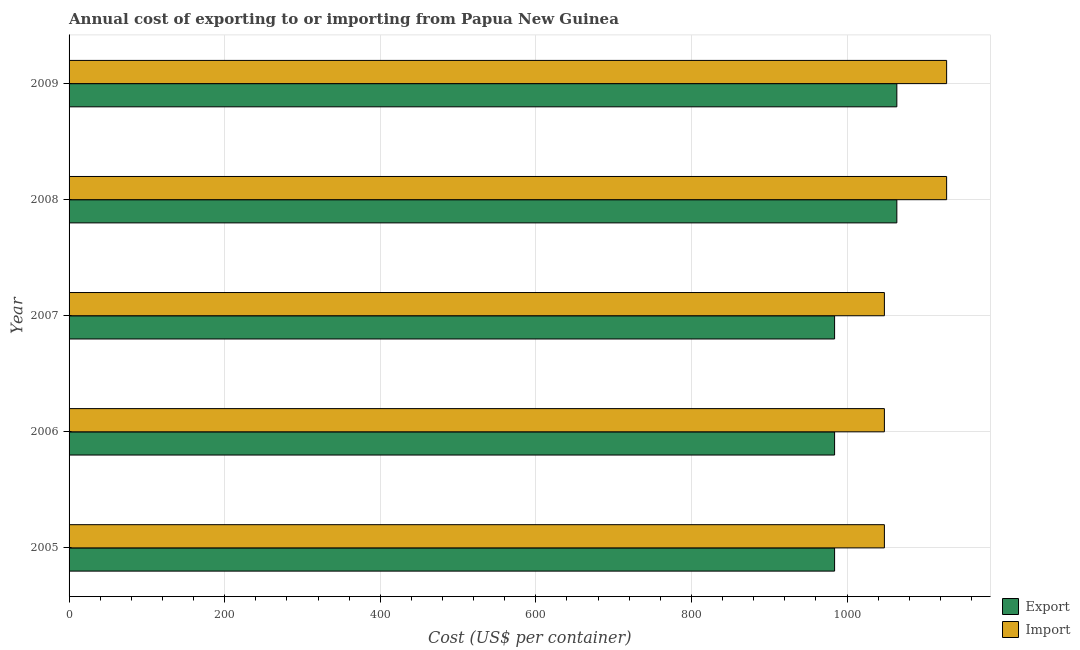How many different coloured bars are there?
Make the answer very short. 2. How many groups of bars are there?
Your response must be concise. 5. Are the number of bars per tick equal to the number of legend labels?
Offer a very short reply. Yes. How many bars are there on the 5th tick from the top?
Keep it short and to the point. 2. How many bars are there on the 2nd tick from the bottom?
Keep it short and to the point. 2. In how many cases, is the number of bars for a given year not equal to the number of legend labels?
Your response must be concise. 0. What is the import cost in 2008?
Your response must be concise. 1128. Across all years, what is the maximum export cost?
Provide a short and direct response. 1064. Across all years, what is the minimum export cost?
Your answer should be compact. 984. In which year was the export cost maximum?
Provide a succinct answer. 2008. In which year was the export cost minimum?
Offer a terse response. 2005. What is the total export cost in the graph?
Keep it short and to the point. 5080. What is the difference between the import cost in 2007 and that in 2008?
Your answer should be very brief. -80. What is the difference between the import cost in 2005 and the export cost in 2007?
Your answer should be very brief. 64. What is the average export cost per year?
Offer a very short reply. 1016. In the year 2005, what is the difference between the import cost and export cost?
Your answer should be compact. 64. What is the ratio of the export cost in 2007 to that in 2008?
Make the answer very short. 0.93. Is the import cost in 2005 less than that in 2006?
Keep it short and to the point. No. Is the difference between the import cost in 2006 and 2008 greater than the difference between the export cost in 2006 and 2008?
Give a very brief answer. No. What is the difference between the highest and the second highest import cost?
Offer a terse response. 0. What is the difference between the highest and the lowest import cost?
Offer a terse response. 80. What does the 1st bar from the top in 2009 represents?
Your response must be concise. Import. What does the 2nd bar from the bottom in 2009 represents?
Give a very brief answer. Import. How many bars are there?
Your response must be concise. 10. How many years are there in the graph?
Give a very brief answer. 5. Are the values on the major ticks of X-axis written in scientific E-notation?
Give a very brief answer. No. What is the title of the graph?
Provide a short and direct response. Annual cost of exporting to or importing from Papua New Guinea. What is the label or title of the X-axis?
Offer a terse response. Cost (US$ per container). What is the Cost (US$ per container) of Export in 2005?
Make the answer very short. 984. What is the Cost (US$ per container) in Import in 2005?
Provide a succinct answer. 1048. What is the Cost (US$ per container) in Export in 2006?
Your response must be concise. 984. What is the Cost (US$ per container) of Import in 2006?
Offer a very short reply. 1048. What is the Cost (US$ per container) in Export in 2007?
Keep it short and to the point. 984. What is the Cost (US$ per container) of Import in 2007?
Offer a terse response. 1048. What is the Cost (US$ per container) of Export in 2008?
Provide a short and direct response. 1064. What is the Cost (US$ per container) in Import in 2008?
Make the answer very short. 1128. What is the Cost (US$ per container) in Export in 2009?
Your answer should be very brief. 1064. What is the Cost (US$ per container) in Import in 2009?
Your answer should be very brief. 1128. Across all years, what is the maximum Cost (US$ per container) of Export?
Provide a short and direct response. 1064. Across all years, what is the maximum Cost (US$ per container) in Import?
Offer a terse response. 1128. Across all years, what is the minimum Cost (US$ per container) of Export?
Provide a short and direct response. 984. Across all years, what is the minimum Cost (US$ per container) of Import?
Keep it short and to the point. 1048. What is the total Cost (US$ per container) in Export in the graph?
Provide a short and direct response. 5080. What is the total Cost (US$ per container) of Import in the graph?
Keep it short and to the point. 5400. What is the difference between the Cost (US$ per container) of Export in 2005 and that in 2006?
Offer a very short reply. 0. What is the difference between the Cost (US$ per container) in Export in 2005 and that in 2007?
Keep it short and to the point. 0. What is the difference between the Cost (US$ per container) in Export in 2005 and that in 2008?
Ensure brevity in your answer.  -80. What is the difference between the Cost (US$ per container) of Import in 2005 and that in 2008?
Ensure brevity in your answer.  -80. What is the difference between the Cost (US$ per container) of Export in 2005 and that in 2009?
Your response must be concise. -80. What is the difference between the Cost (US$ per container) of Import in 2005 and that in 2009?
Ensure brevity in your answer.  -80. What is the difference between the Cost (US$ per container) of Export in 2006 and that in 2007?
Make the answer very short. 0. What is the difference between the Cost (US$ per container) of Import in 2006 and that in 2007?
Make the answer very short. 0. What is the difference between the Cost (US$ per container) of Export in 2006 and that in 2008?
Offer a very short reply. -80. What is the difference between the Cost (US$ per container) in Import in 2006 and that in 2008?
Ensure brevity in your answer.  -80. What is the difference between the Cost (US$ per container) in Export in 2006 and that in 2009?
Keep it short and to the point. -80. What is the difference between the Cost (US$ per container) in Import in 2006 and that in 2009?
Offer a terse response. -80. What is the difference between the Cost (US$ per container) in Export in 2007 and that in 2008?
Your answer should be very brief. -80. What is the difference between the Cost (US$ per container) in Import in 2007 and that in 2008?
Your answer should be compact. -80. What is the difference between the Cost (US$ per container) in Export in 2007 and that in 2009?
Provide a succinct answer. -80. What is the difference between the Cost (US$ per container) in Import in 2007 and that in 2009?
Your response must be concise. -80. What is the difference between the Cost (US$ per container) of Export in 2008 and that in 2009?
Your answer should be compact. 0. What is the difference between the Cost (US$ per container) of Export in 2005 and the Cost (US$ per container) of Import in 2006?
Give a very brief answer. -64. What is the difference between the Cost (US$ per container) of Export in 2005 and the Cost (US$ per container) of Import in 2007?
Offer a very short reply. -64. What is the difference between the Cost (US$ per container) of Export in 2005 and the Cost (US$ per container) of Import in 2008?
Your response must be concise. -144. What is the difference between the Cost (US$ per container) in Export in 2005 and the Cost (US$ per container) in Import in 2009?
Your response must be concise. -144. What is the difference between the Cost (US$ per container) in Export in 2006 and the Cost (US$ per container) in Import in 2007?
Make the answer very short. -64. What is the difference between the Cost (US$ per container) of Export in 2006 and the Cost (US$ per container) of Import in 2008?
Give a very brief answer. -144. What is the difference between the Cost (US$ per container) of Export in 2006 and the Cost (US$ per container) of Import in 2009?
Offer a very short reply. -144. What is the difference between the Cost (US$ per container) in Export in 2007 and the Cost (US$ per container) in Import in 2008?
Offer a terse response. -144. What is the difference between the Cost (US$ per container) in Export in 2007 and the Cost (US$ per container) in Import in 2009?
Offer a terse response. -144. What is the difference between the Cost (US$ per container) of Export in 2008 and the Cost (US$ per container) of Import in 2009?
Offer a terse response. -64. What is the average Cost (US$ per container) of Export per year?
Your response must be concise. 1016. What is the average Cost (US$ per container) in Import per year?
Your response must be concise. 1080. In the year 2005, what is the difference between the Cost (US$ per container) of Export and Cost (US$ per container) of Import?
Your answer should be compact. -64. In the year 2006, what is the difference between the Cost (US$ per container) in Export and Cost (US$ per container) in Import?
Your answer should be very brief. -64. In the year 2007, what is the difference between the Cost (US$ per container) of Export and Cost (US$ per container) of Import?
Your response must be concise. -64. In the year 2008, what is the difference between the Cost (US$ per container) in Export and Cost (US$ per container) in Import?
Provide a short and direct response. -64. In the year 2009, what is the difference between the Cost (US$ per container) of Export and Cost (US$ per container) of Import?
Your response must be concise. -64. What is the ratio of the Cost (US$ per container) of Import in 2005 to that in 2006?
Make the answer very short. 1. What is the ratio of the Cost (US$ per container) of Export in 2005 to that in 2008?
Keep it short and to the point. 0.92. What is the ratio of the Cost (US$ per container) of Import in 2005 to that in 2008?
Provide a succinct answer. 0.93. What is the ratio of the Cost (US$ per container) in Export in 2005 to that in 2009?
Give a very brief answer. 0.92. What is the ratio of the Cost (US$ per container) in Import in 2005 to that in 2009?
Offer a very short reply. 0.93. What is the ratio of the Cost (US$ per container) of Export in 2006 to that in 2007?
Your response must be concise. 1. What is the ratio of the Cost (US$ per container) in Export in 2006 to that in 2008?
Provide a succinct answer. 0.92. What is the ratio of the Cost (US$ per container) of Import in 2006 to that in 2008?
Keep it short and to the point. 0.93. What is the ratio of the Cost (US$ per container) in Export in 2006 to that in 2009?
Offer a terse response. 0.92. What is the ratio of the Cost (US$ per container) in Import in 2006 to that in 2009?
Provide a succinct answer. 0.93. What is the ratio of the Cost (US$ per container) in Export in 2007 to that in 2008?
Provide a short and direct response. 0.92. What is the ratio of the Cost (US$ per container) of Import in 2007 to that in 2008?
Keep it short and to the point. 0.93. What is the ratio of the Cost (US$ per container) of Export in 2007 to that in 2009?
Offer a very short reply. 0.92. What is the ratio of the Cost (US$ per container) of Import in 2007 to that in 2009?
Your answer should be very brief. 0.93. What is the ratio of the Cost (US$ per container) of Import in 2008 to that in 2009?
Offer a very short reply. 1. What is the difference between the highest and the second highest Cost (US$ per container) of Import?
Offer a very short reply. 0. What is the difference between the highest and the lowest Cost (US$ per container) of Export?
Your answer should be compact. 80. What is the difference between the highest and the lowest Cost (US$ per container) of Import?
Provide a succinct answer. 80. 